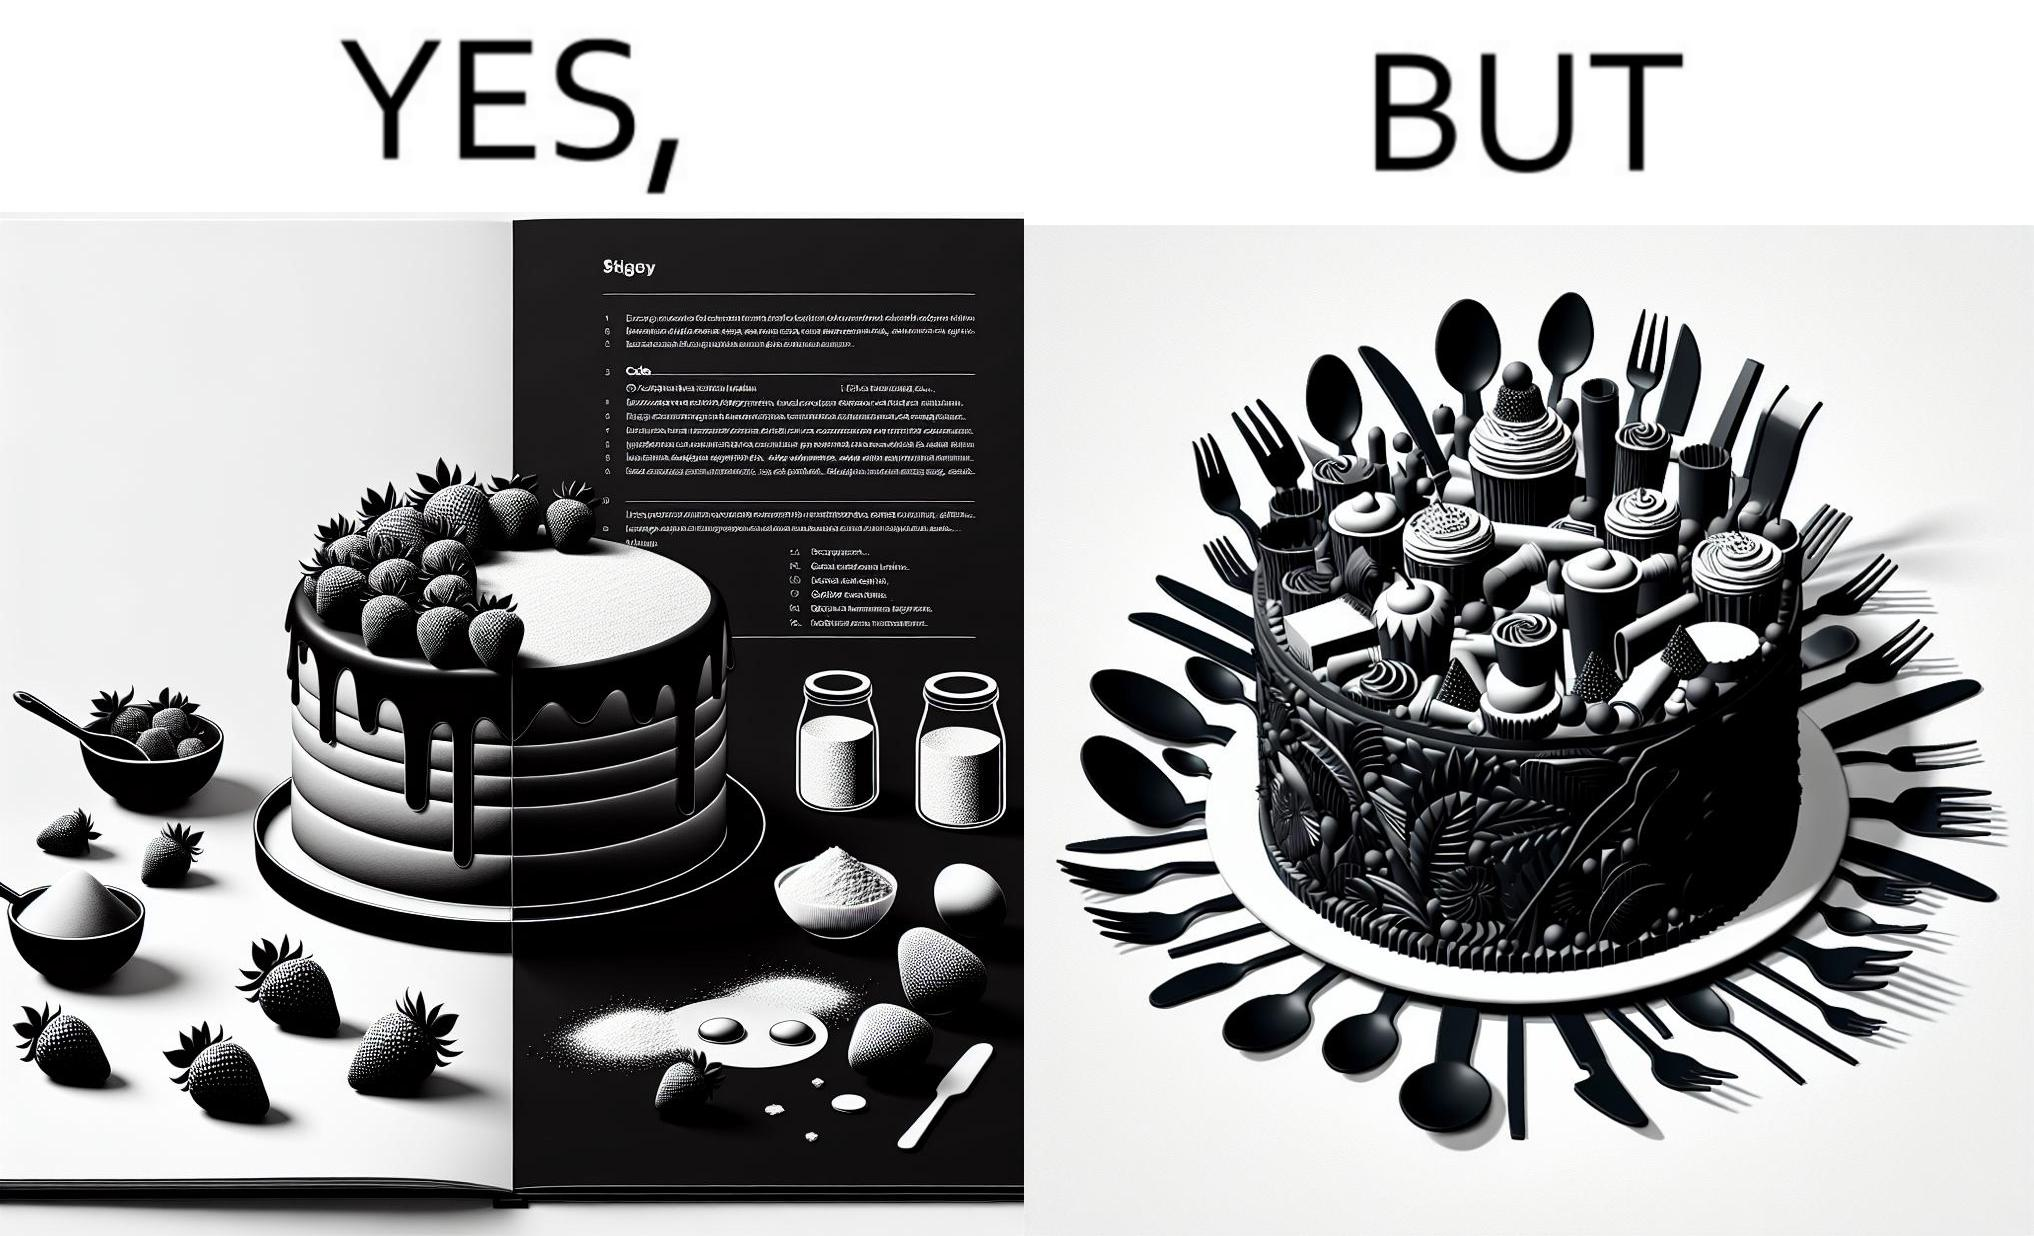Describe the content of this image. The image is funny, as when making a strawberry cake using  a recipe book, the outcome is not quite what is expected, and one has to wash the used utensils afterwards as well. 